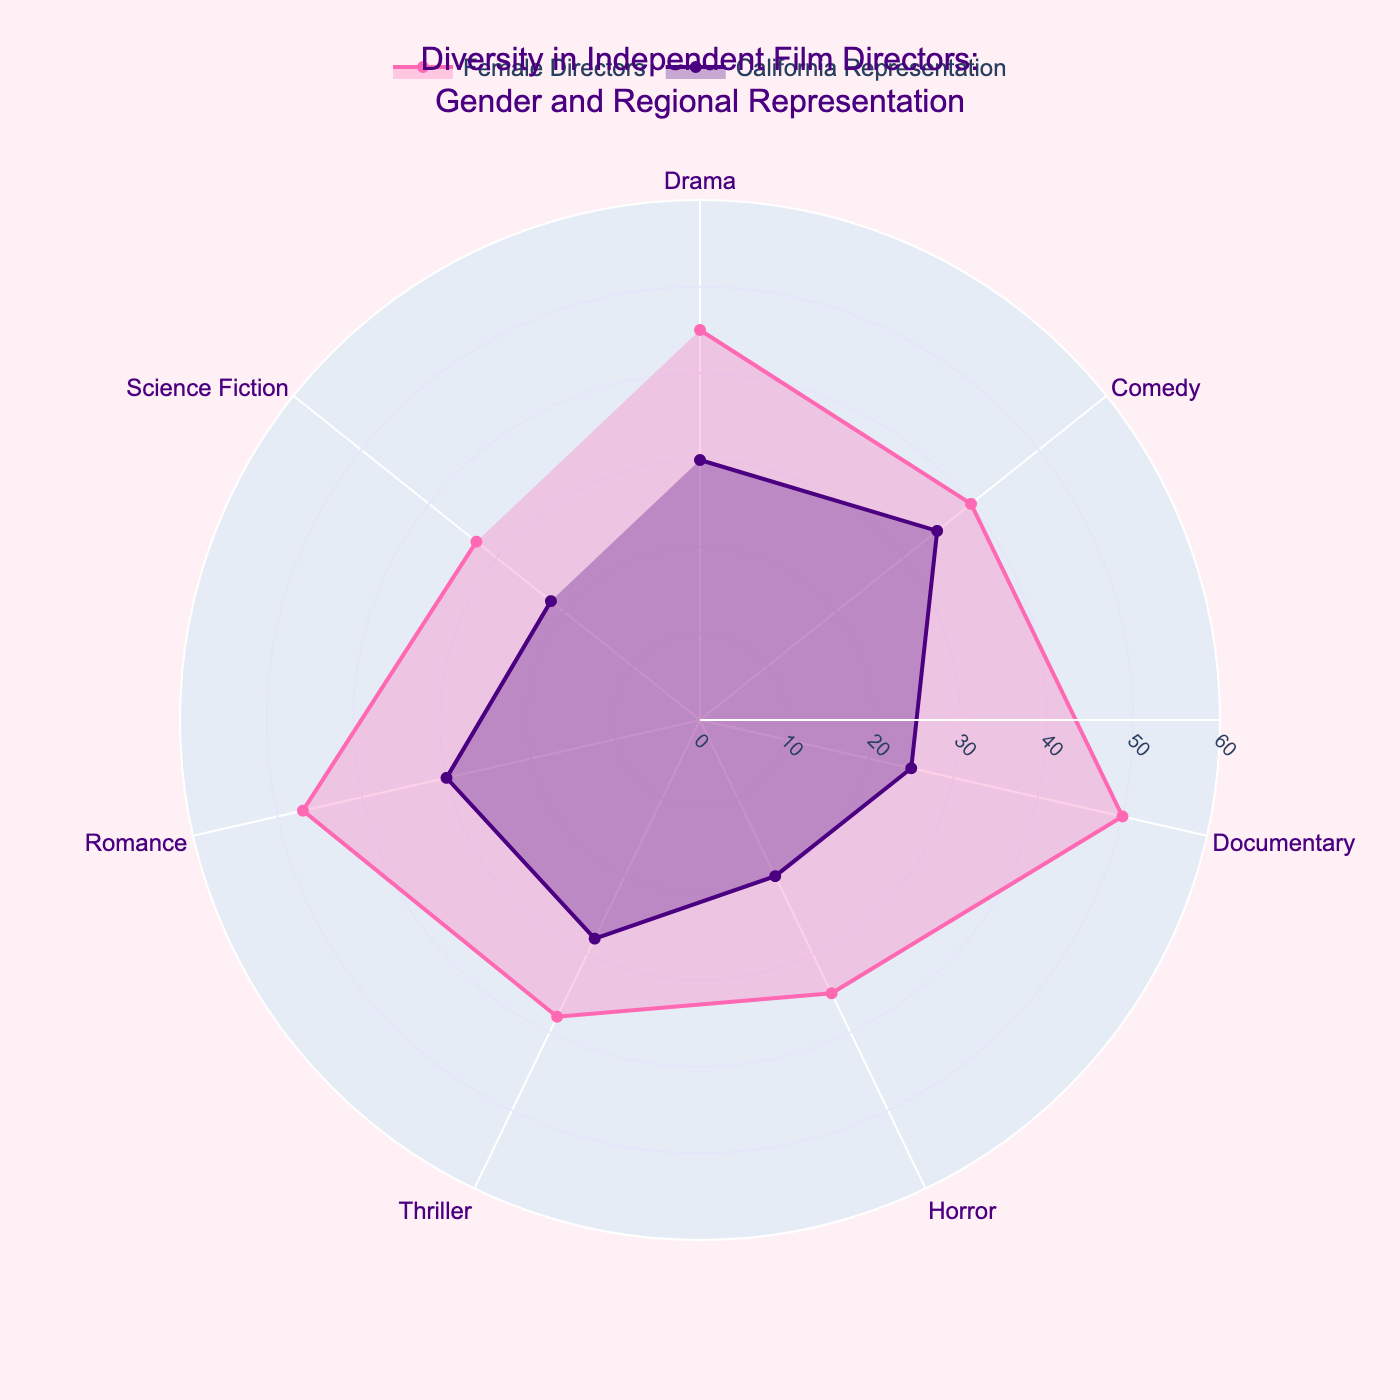What's the title of the radar chart? The title is located at the top center of the chart and summarizes the data being presented. The title is "Diversity in Independent Film Directors: Gender and Regional Representation".
Answer: Diversity in Independent Film Directors: Gender and Regional Representation Which category has the highest percentage of female directors? Look for the category with the highest value on the radar chart in the "Female Directors" trace. The category "Documentary" has the highest percentage at 50%.
Answer: Documentary What is the average percentage of regional representation (California) across all categories? Sum up the percentages for each category listed for California representation (30 + 35 + 25 + 20 + 28 + 30 + 22) and then divide by the number of categories, which is 7. The calculation is (30 + 35 + 25 + 20 + 28 + 30 + 22) / 7 = 190 / 7 = approximately 27.14.
Answer: 27.14 Which category has the largest difference between female directors and California representation? Calculate the absolute difference for each category between "Percentage of Female Directors" and "Percentage of Regional Representation (California)". The differences are: Drama (15), Comedy (5), Documentary (25), Horror (15), Thriller (10), Romance (17), Science Fiction (11). The largest difference is in the Documentary category with a difference of 25.
Answer: Documentary What is the range of the radial axis? The radial axis range is represented by the outermost circular line on the chart. According to the configuration, the range is from 0 to 60.
Answer: 0 to 60 Which category has the lowest percentage of female directors? Identify the category on the radar chart with the lowest value in the "Female Directors" trace. The category "Science Fiction" has the lowest percentage at 33%.
Answer: Science Fiction Between the categories Drama and Romance, which one has a higher percentage of regional representation from California? Compare the California representation percentages for Drama (30%) and Romance (30%) on the radar chart. Both categories have the same percentage at 30%.
Answer: Both are equal Is there any category where both the percentage of female directors and California representation are above 40%? Scan through the radar chart and check both traces for each category to see if both exceed 40%. No category satisfies this condition.
Answer: No How does the percentage of female directors in the Horror category compare with that in the Thriller category? Look at the radar chart and compare the percentages for "Female Directors" in Horror (35%) and Thriller (38%). The percentage in Thriller is slightly higher.
Answer: Thriller is higher 